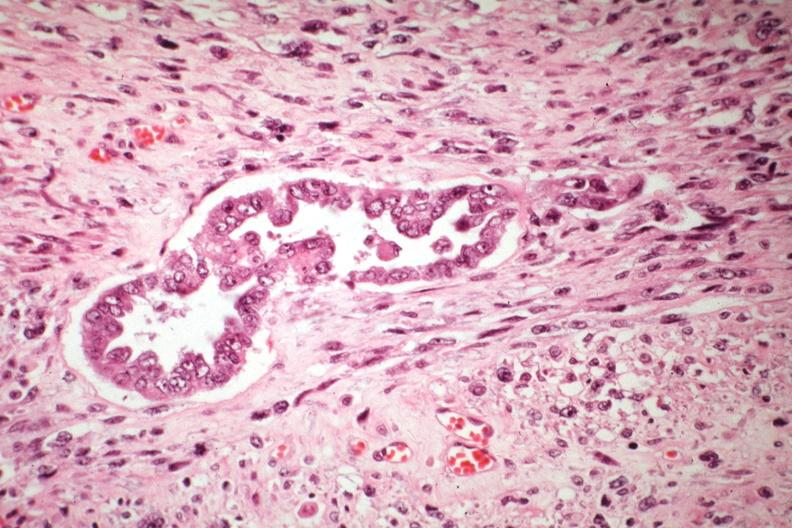what is present?
Answer the question using a single word or phrase. Uterus 